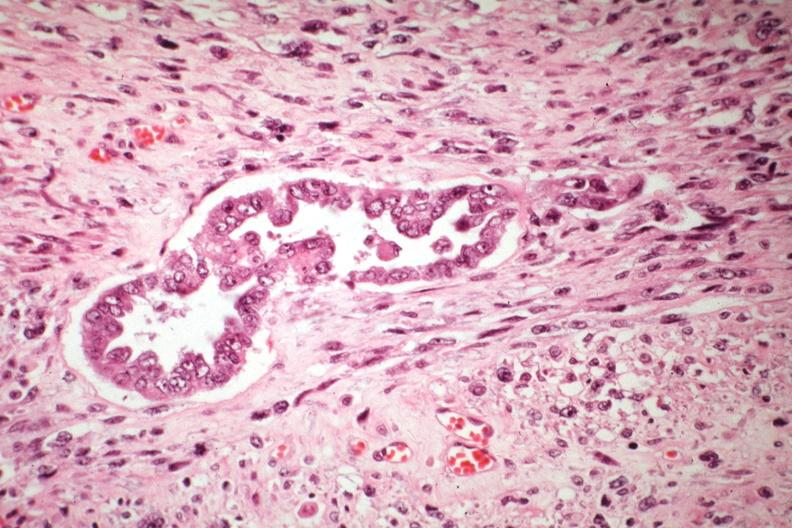what is present?
Answer the question using a single word or phrase. Uterus 